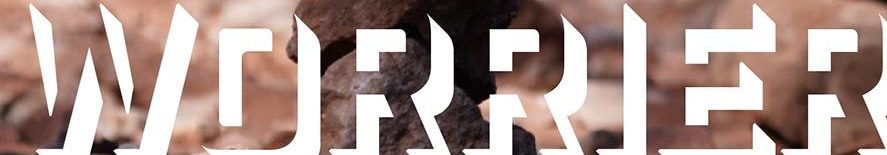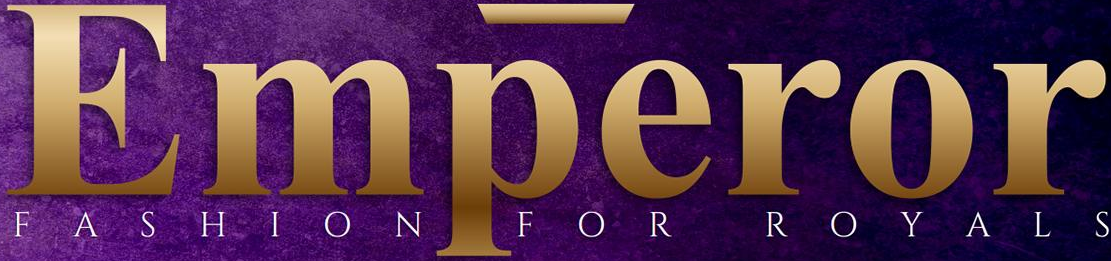Identify the words shown in these images in order, separated by a semicolon. WORRIER; Emperor 